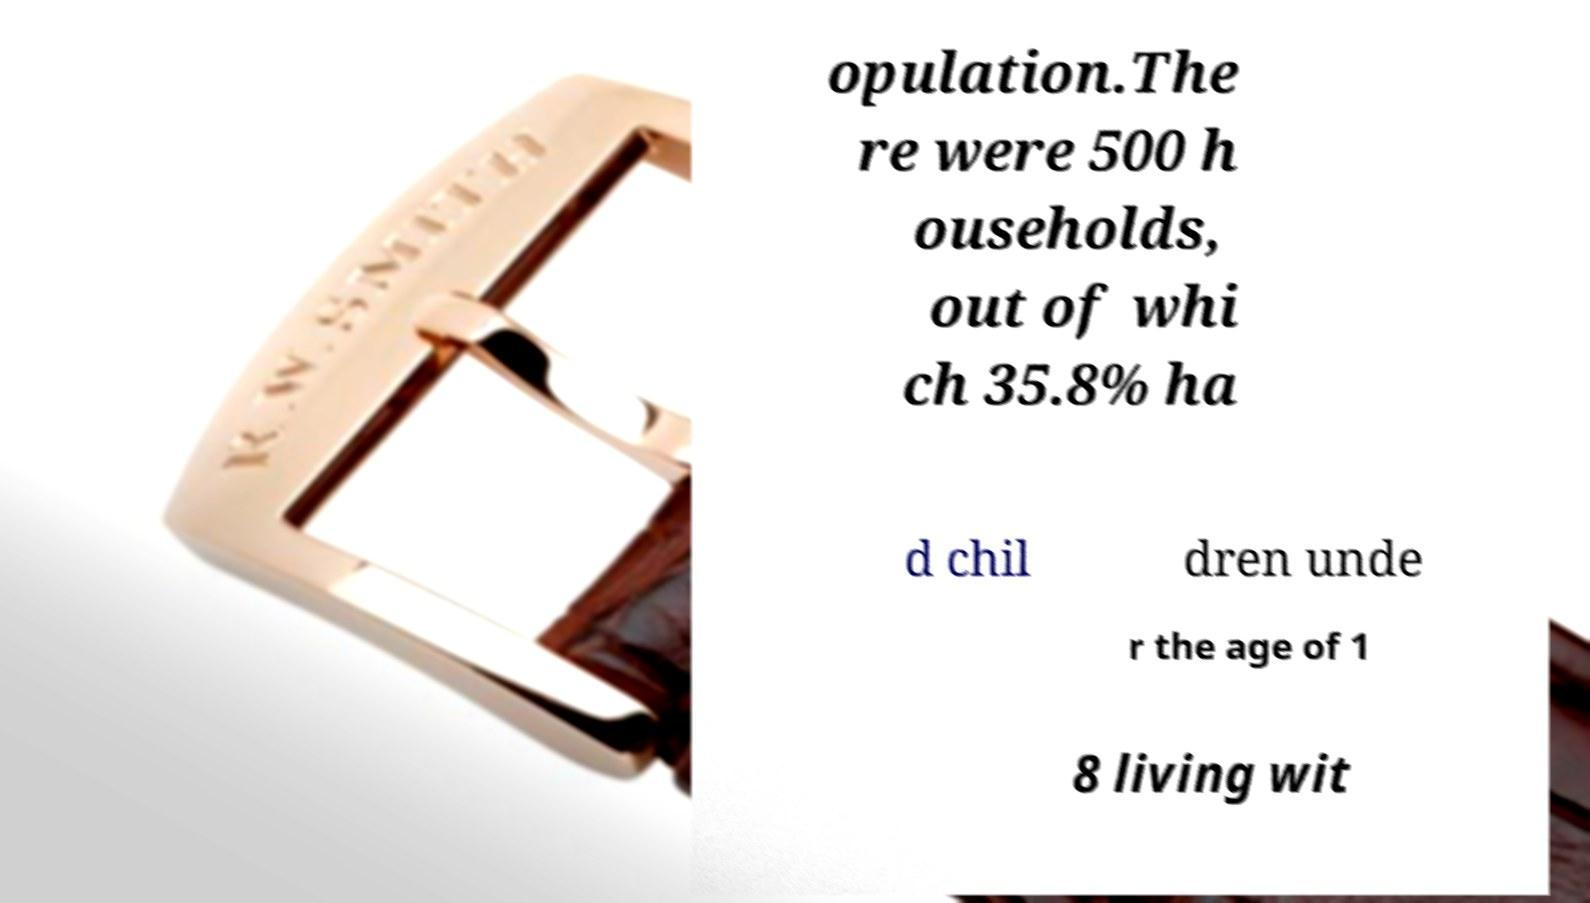Please identify and transcribe the text found in this image. opulation.The re were 500 h ouseholds, out of whi ch 35.8% ha d chil dren unde r the age of 1 8 living wit 